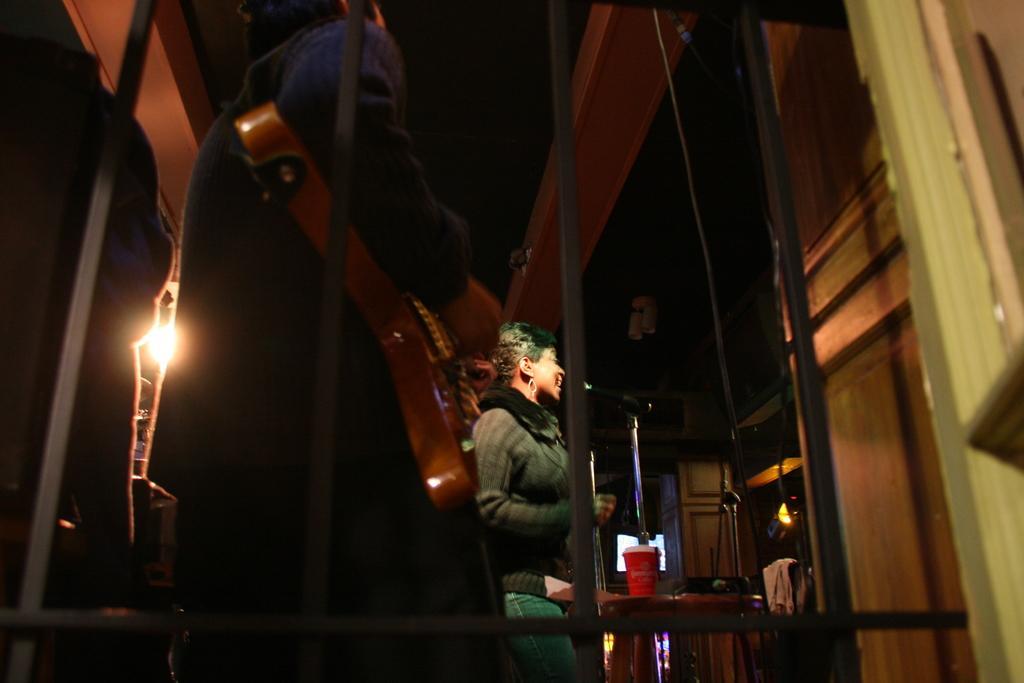How would you summarize this image in a sentence or two? As we can see in the image there is a woman standing, wall, door, shelves and light. The image is little dark. 